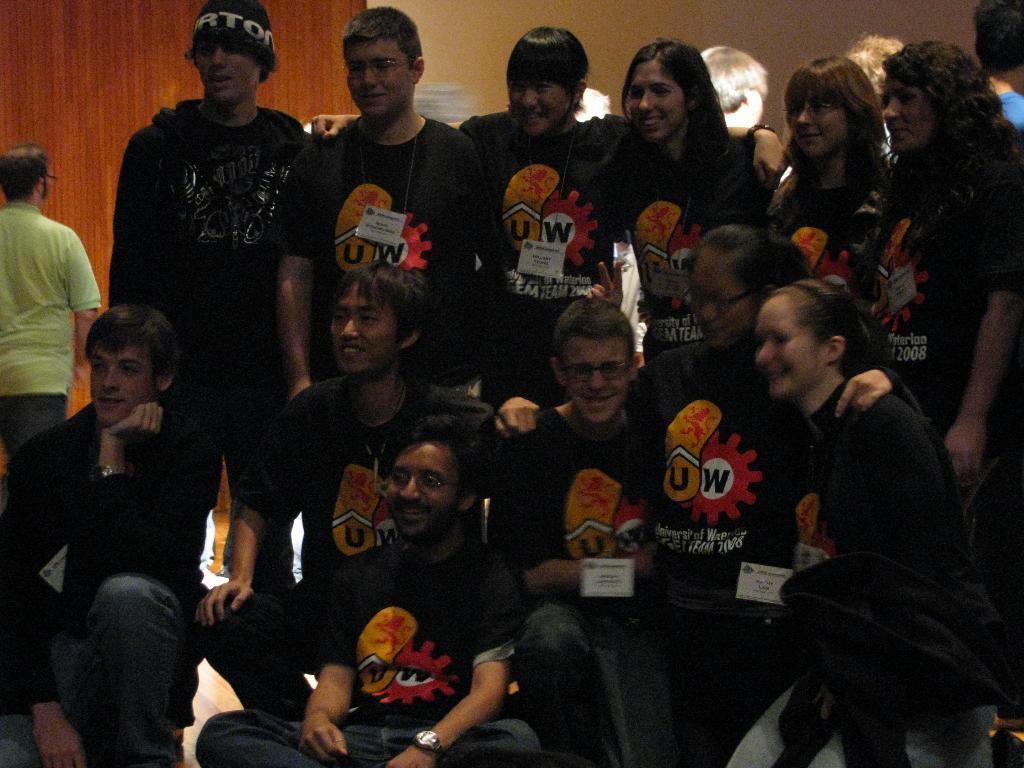Could you give a brief overview of what you see in this image? In this image we can see some people wearing a black t-shirt and posing for a photo. There is a person walking and we can see the wall in the background. 